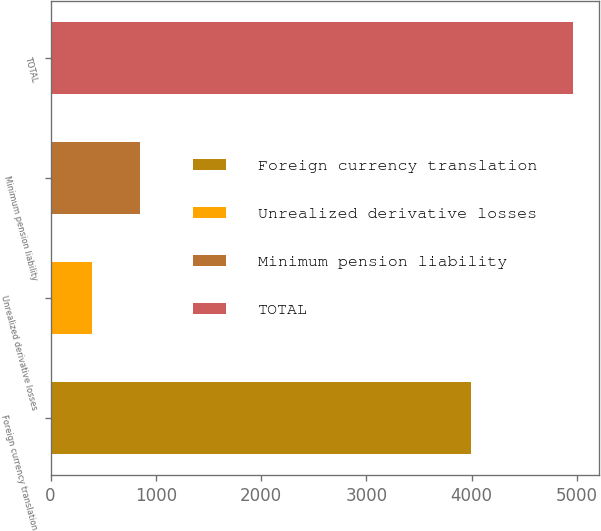Convert chart to OTSL. <chart><loc_0><loc_0><loc_500><loc_500><bar_chart><fcel>Foreign currency translation<fcel>Unrealized derivative losses<fcel>Minimum pension liability<fcel>TOTAL<nl><fcel>3990<fcel>397<fcel>853.2<fcel>4959<nl></chart> 